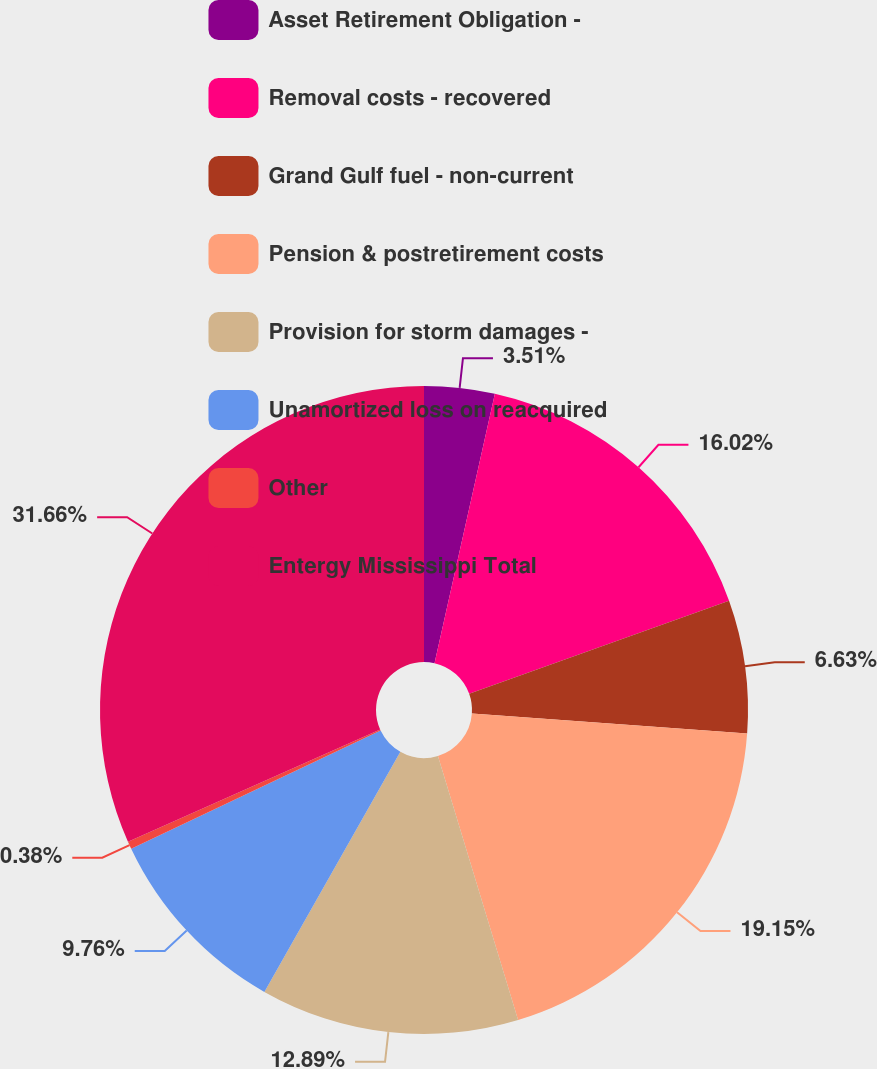Convert chart. <chart><loc_0><loc_0><loc_500><loc_500><pie_chart><fcel>Asset Retirement Obligation -<fcel>Removal costs - recovered<fcel>Grand Gulf fuel - non-current<fcel>Pension & postretirement costs<fcel>Provision for storm damages -<fcel>Unamortized loss on reacquired<fcel>Other<fcel>Entergy Mississippi Total<nl><fcel>3.51%<fcel>16.02%<fcel>6.63%<fcel>19.15%<fcel>12.89%<fcel>9.76%<fcel>0.38%<fcel>31.66%<nl></chart> 